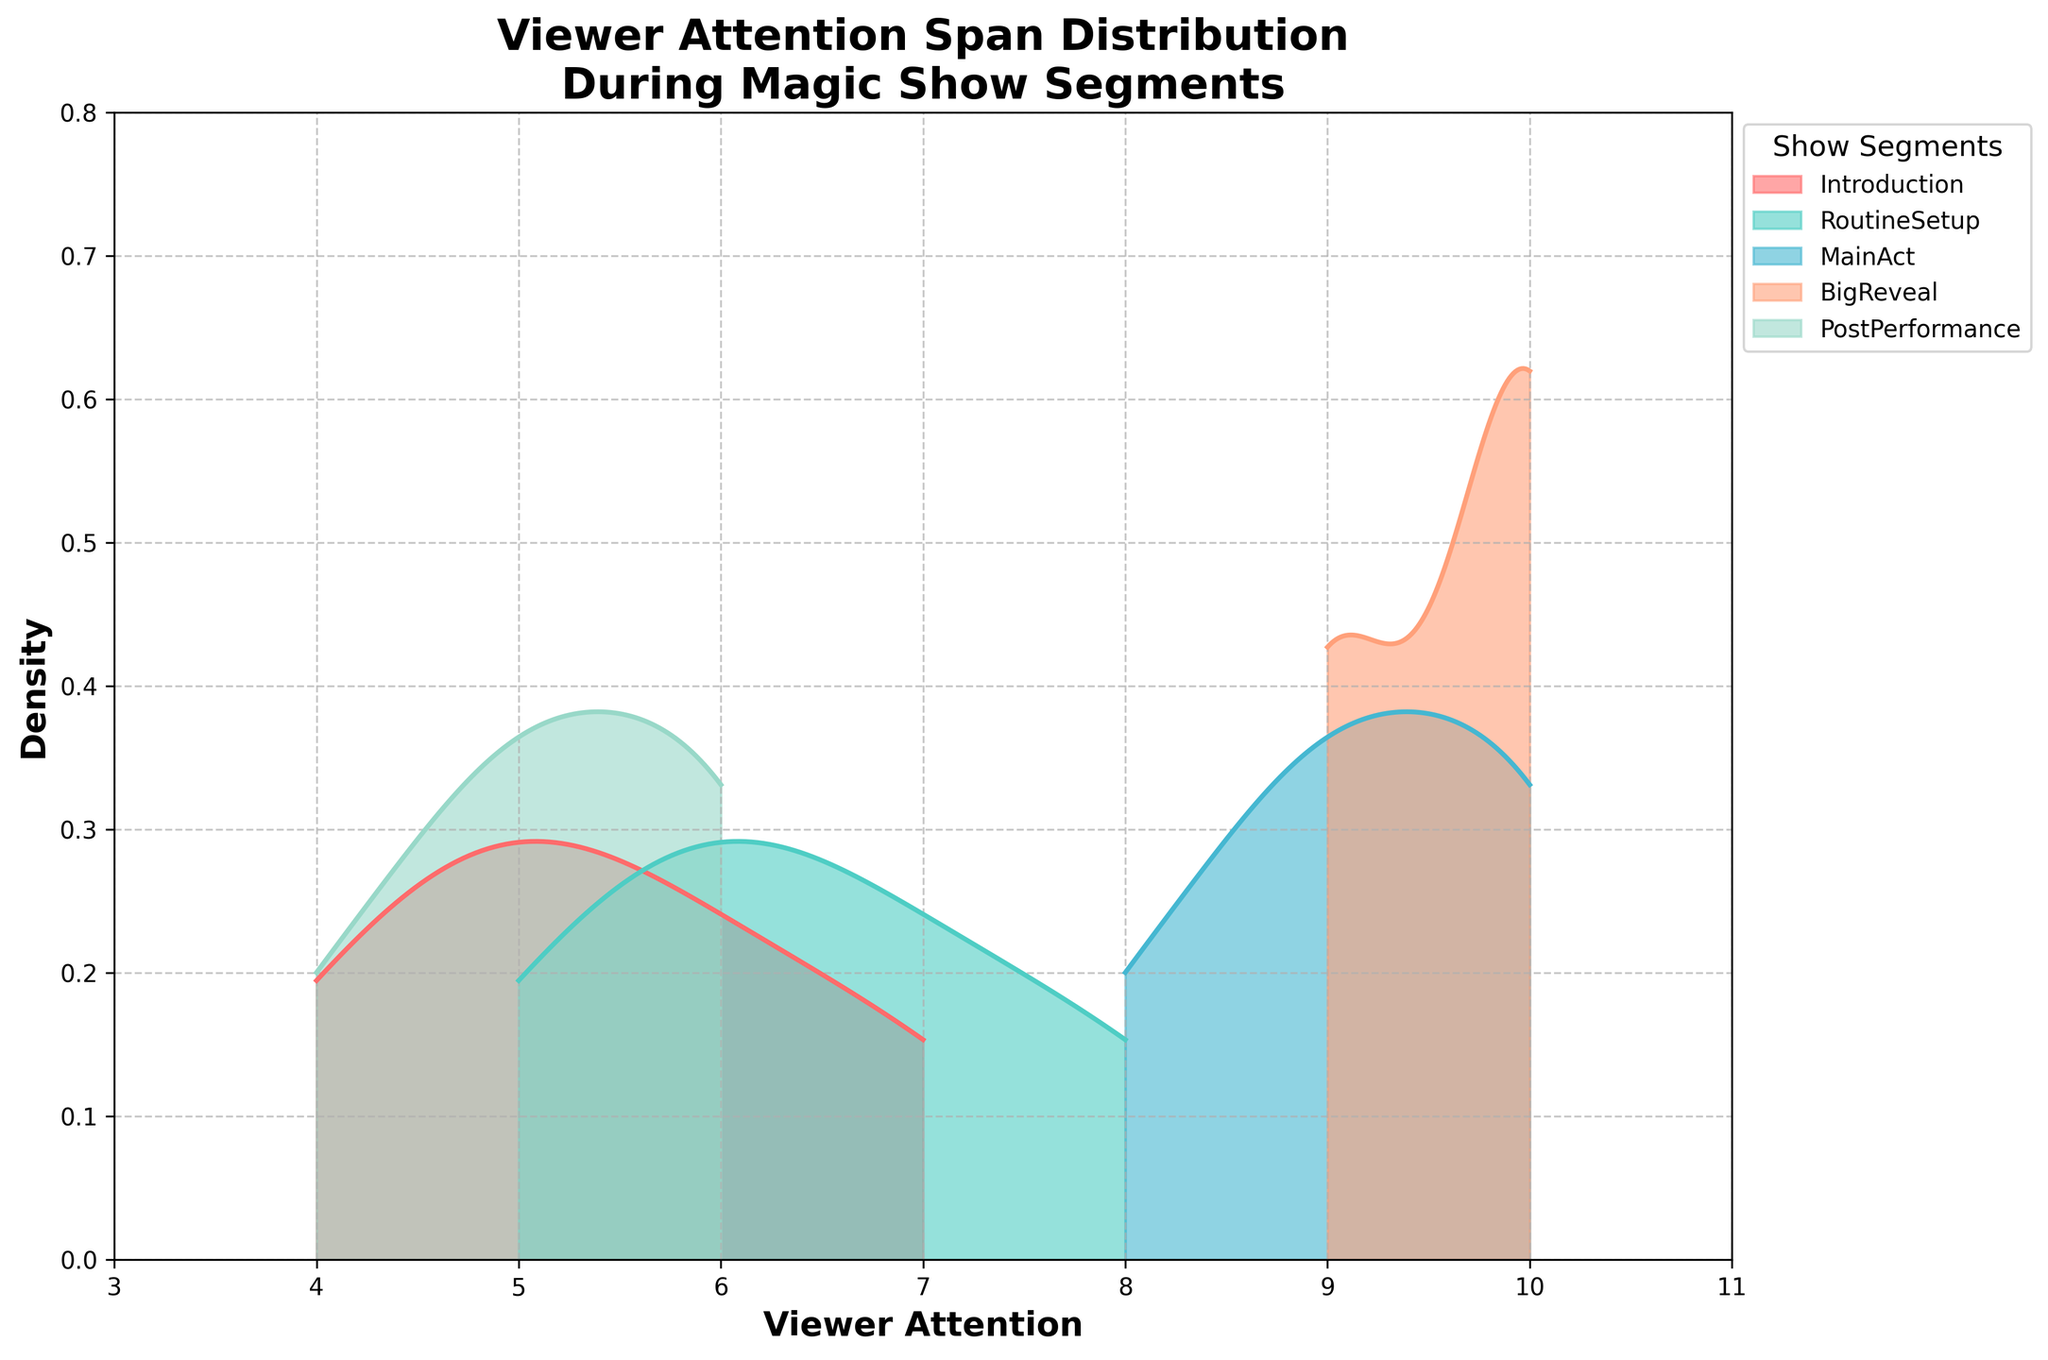what is the title of the figure? The title is usually the first piece of text displayed at the top of the figure. In this case, it indicates what the plot is about.
Answer: Viewer Attention Span Distribution During Magic Show Segments which show segment has the highest peak in density? The highest peak in density can be identified by looking at the tallest point in the plot. For this figure, it's evident from the peaks.
Answer: MainAct how does the viewer attention in the introduction segment compare to the post-performance segment? Compare the density curves of the Introduction and PostPerformance segments. Both appear to have similar peak density values, suggesting similar viewer attention spans.
Answer: Similar what is the range of the x-axis? The x-axis range can be determined by looking at the starting and ending values on this axis. In this plot, it ranges from the minimum to the maximum values displayed.
Answer: 3 to 11 which show segment has the widest spread of viewer attention spans? The segment with the widest spread will have the widest range on the x-axis. It can be seen where the density curve covers the most extensive range of attention spans.
Answer: MainAct which segment has more viewer attention: routine setup or big reveal? Compare the density curves of RoutineSetup and BigReveal segments. BigReveal has a higher peak density, indicating more viewer attention.
Answer: BigReveal what is the color used for the 'main act' segment in the plot? Look for the legend and the color associated with the MainAct label to determine the color used in the plot.
Answer: Blue is there a segment where viewer attention consistently hits the maximum value? Analyze if there's a segment where the density curve indicates frequent maximum values of viewer attention. For example, BigReveal consistently reaches 10.
Answer: BigReveal which segments have viewer attention levels of 6 as the most common? Check where the density curves have a peak at the viewer attention level of 6. Both Introduction and PostPerformance segments have significant peaks at this value.
Answer: Introduction and PostPerformance 